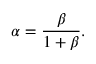<formula> <loc_0><loc_0><loc_500><loc_500>\alpha = \frac { \beta } { 1 + \beta } .</formula> 